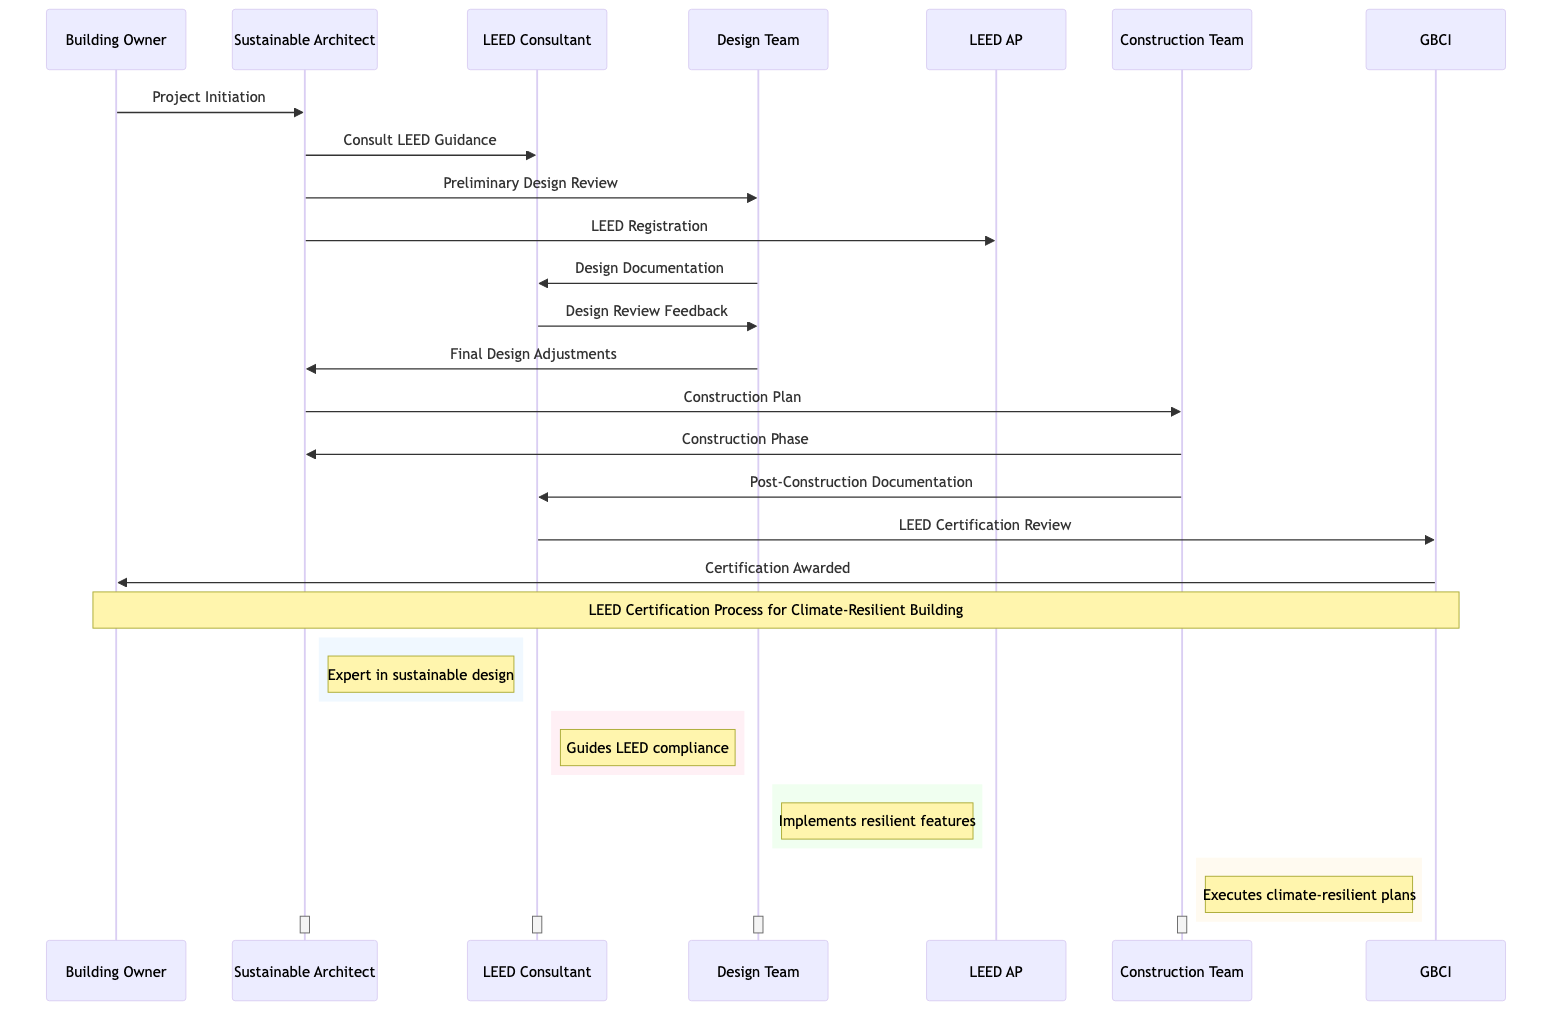What is the first step in the process? The first step is initiated by the Building Owner, who defines the goal of achieving LEED certification. The sequence diagram shows this as the initial action leading into the process.
Answer: Project Initiation Who consults the LEED Consultant? The Sustainable Architect is depicted as the party that reaches out to the LEED Consultant for guidance. This relationship is clearly mapped in the sequence diagram.
Answer: Sustainable Architect What step follows the Design Review Feedback? After the Design Review Feedback is provided by the LEED Consultant, the next action taken is the Final Design Adjustments by the Design Team. The arrows connecting these steps indicate the flow.
Answer: Final Design Adjustments How many participants are involved in the certification process? There are six distinct participants in the diagram: Building Owner, Sustainable Architect, LEED Consultant, Design Team, Construction Team, and LEED Accredited Professional. Counting each participant shows this total.
Answer: 6 Who submits post-construction documentation? The Construction Team is responsible for submitting the post-construction documentation for LEED certification as indicated in the flow of the diagram.
Answer: Construction Team What is the relationship between the LEED Consultant and GBCI? The LEED Consultant is responsible for submitting the final documentation to the Green Building Certification Institute (GBCI) for review. This is represented as a directional line in the diagram.
Answer: Submission What is the final outcome awarded by GBCI? The final outcome shown in the diagram is the awarding of Certification to the Building Owner by GBCI, indicating completion of the certification process.
Answer: Certification Awarded What is the role of the Design Team? The Design Team is tasked with implementing climate-resilient features and documenting them for LEED certification, which is presented in multiple steps of the diagram.
Answer: Implements resilient features What happens after the Construction Phase? Following the Construction Phase, the Construction Team submits the post-construction documentation for review, which is part of the certification process. The arrows indicate this sequential flow.
Answer: Post-Construction Documentation 